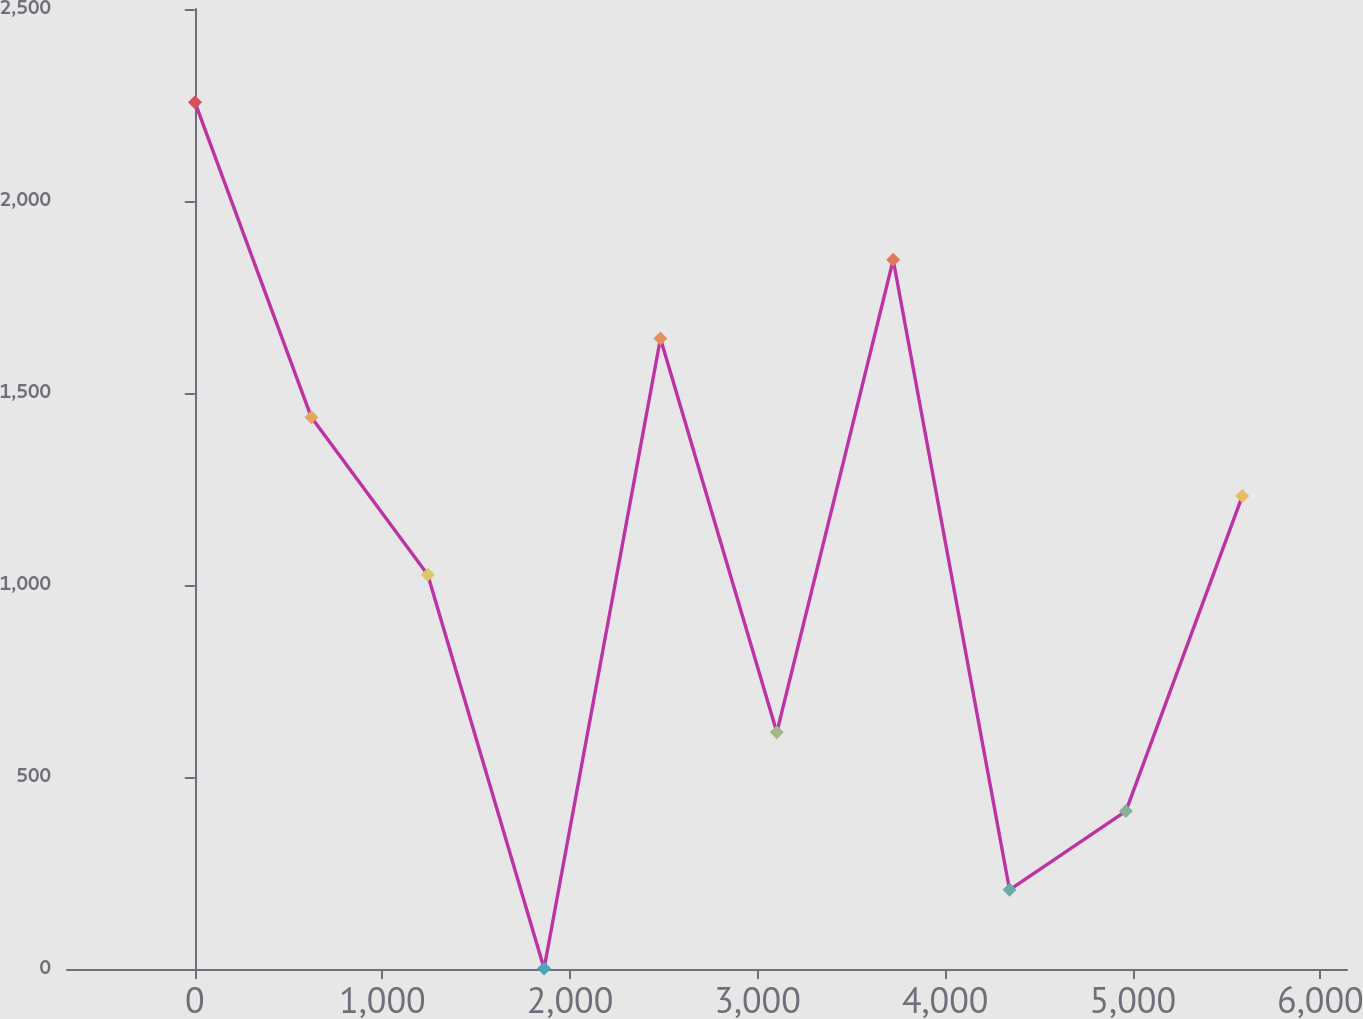Convert chart to OTSL. <chart><loc_0><loc_0><loc_500><loc_500><line_chart><ecel><fcel>December 31,<nl><fcel>1.15<fcel>2257.01<nl><fcel>621.44<fcel>1436.71<nl><fcel>1241.73<fcel>1026.56<nl><fcel>1862.02<fcel>1.17<nl><fcel>2482.31<fcel>1641.79<nl><fcel>3102.6<fcel>616.4<nl><fcel>3722.89<fcel>1846.87<nl><fcel>4343.18<fcel>206.25<nl><fcel>4963.47<fcel>411.33<nl><fcel>5583.76<fcel>1231.63<nl><fcel>6204.05<fcel>2051.94<nl><fcel>6824.34<fcel>821.48<nl></chart> 